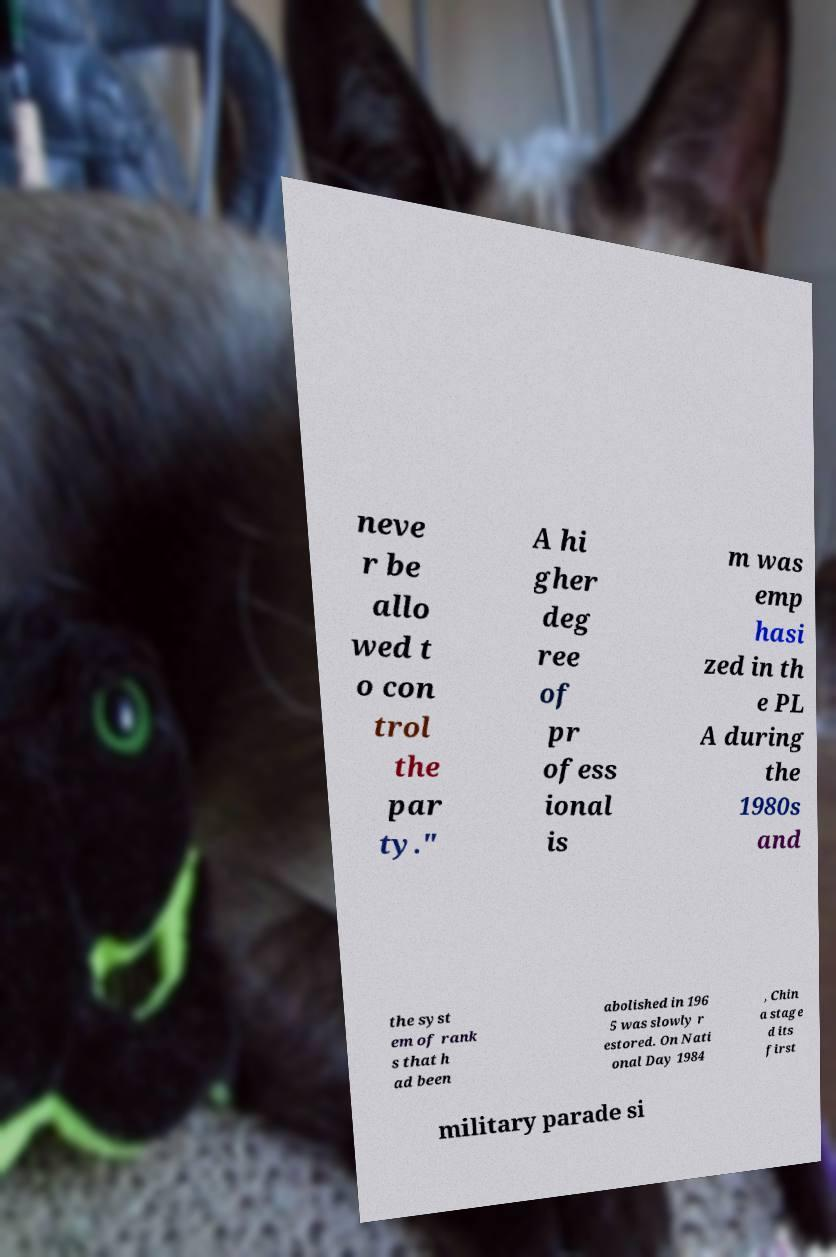Can you read and provide the text displayed in the image?This photo seems to have some interesting text. Can you extract and type it out for me? neve r be allo wed t o con trol the par ty." A hi gher deg ree of pr ofess ional is m was emp hasi zed in th e PL A during the 1980s and the syst em of rank s that h ad been abolished in 196 5 was slowly r estored. On Nati onal Day 1984 , Chin a stage d its first military parade si 